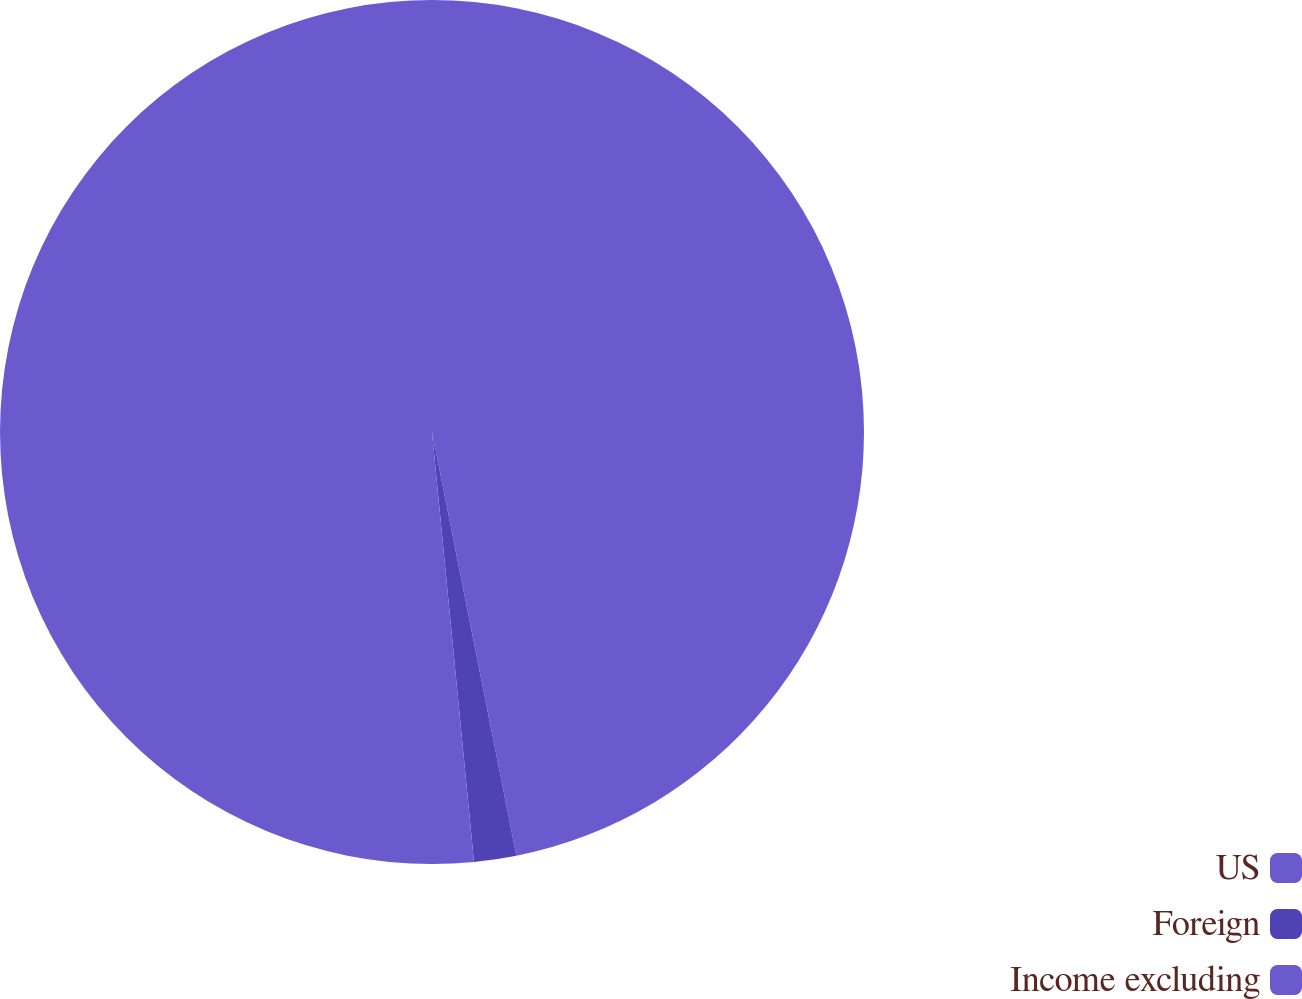Convert chart to OTSL. <chart><loc_0><loc_0><loc_500><loc_500><pie_chart><fcel>US<fcel>Foreign<fcel>Income excluding<nl><fcel>46.87%<fcel>1.58%<fcel>51.55%<nl></chart> 